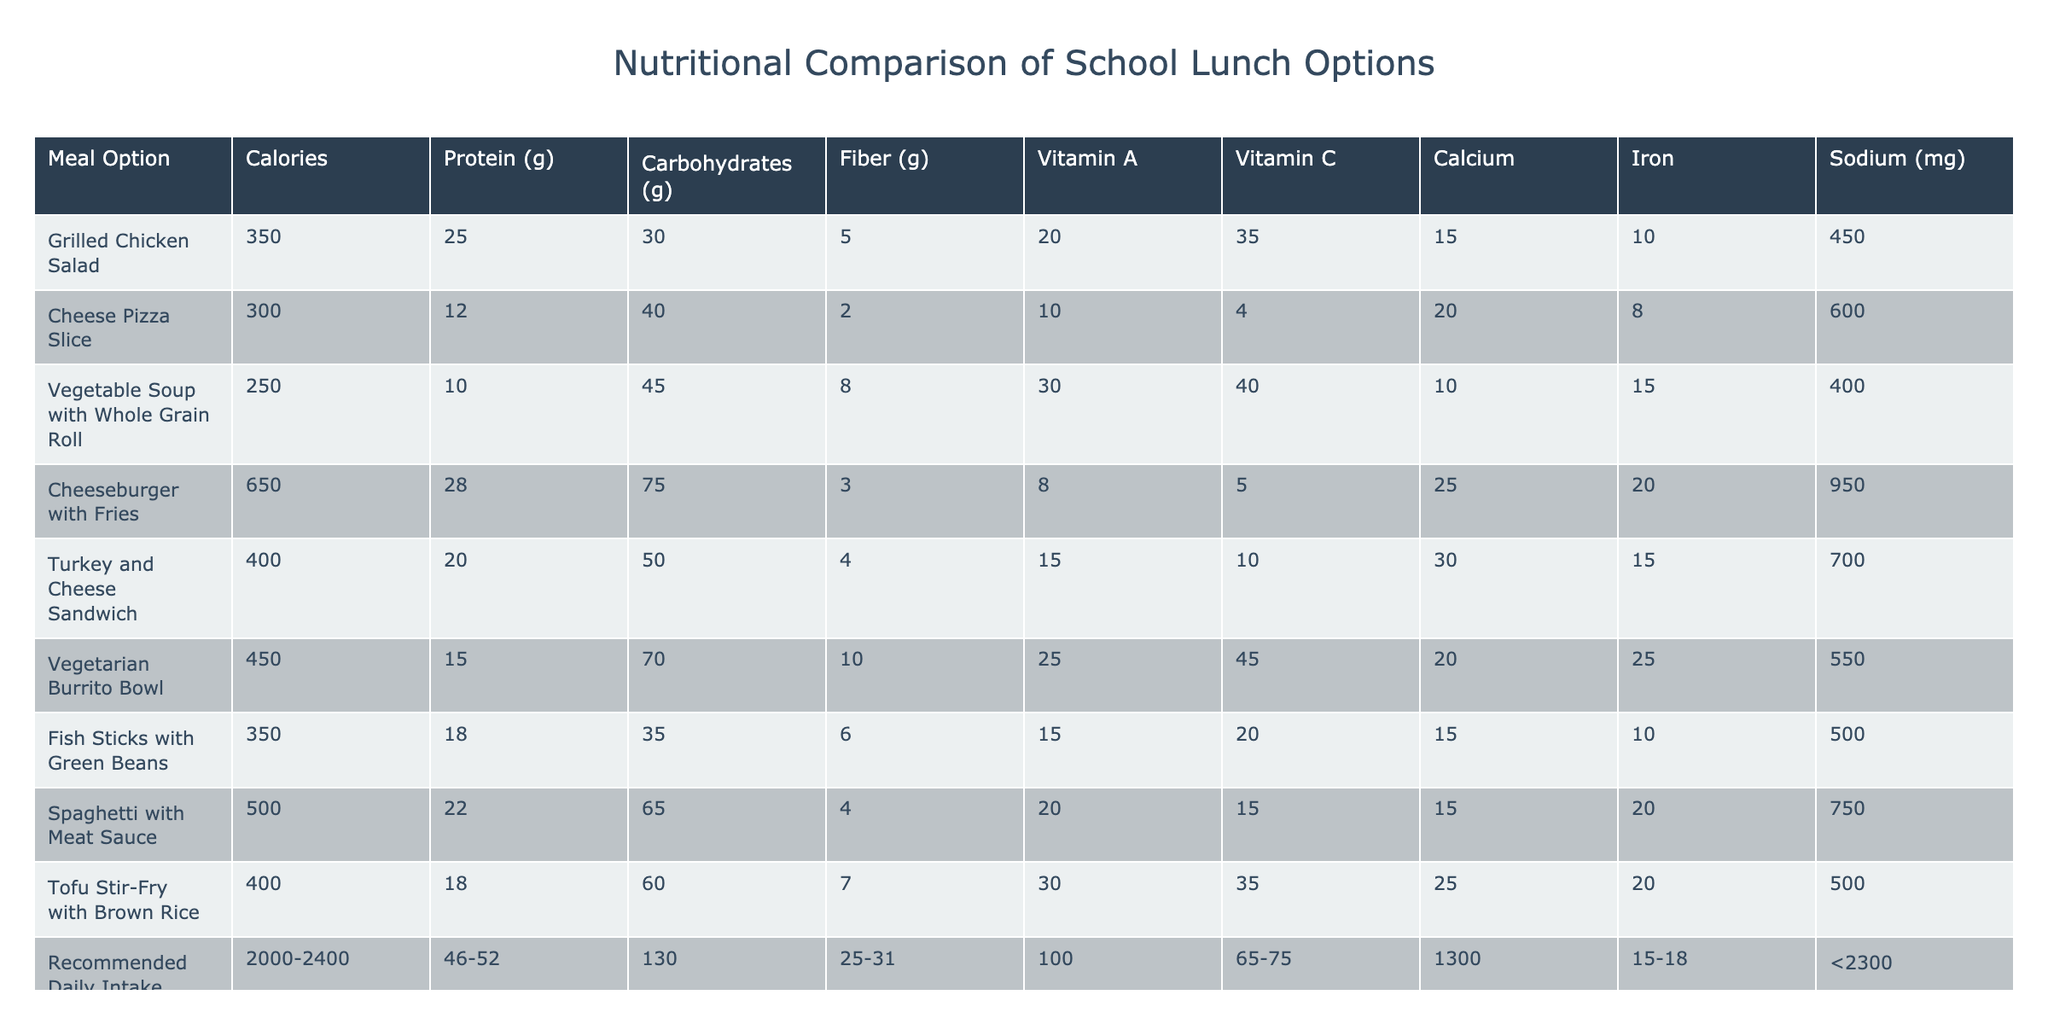What is the calorie content of the Cheeseburger with Fries? The table lists the Cheeseburger with Fries under the Meal Option column. Next to it, in the Calories column, the value is given as 650.
Answer: 650 Which meal option has the highest protein content? Looking at the Protein (g) column, the highest value is next to the Cheeseburger with Fries, which has 28 grams of protein.
Answer: Cheeseburger with Fries What is the total amount of Sodium in the Vegetarian Burrito Bowl and the Turkey and Cheese Sandwich combined? The Sodium content for the Vegetarian Burrito Bowl is 550 mg and for the Turkey and Cheese Sandwich, it is 700 mg. Adding these together gives 550 + 700 = 1250 mg.
Answer: 1250 mg Is the Cheese Pizza Slice above or below the recommended daily intake for Calcium? The recommended daily intake for Calcium is 1300 mg, while the Cheese Pizza Slice has 20% of the daily value. Converting this percentage to mg gives (20/100) * 1300 = 260 mg, which is below the recommended intake.
Answer: Below Which meal option has the highest Vitamin A content? The Vitamin A (%DV) column shows that Vegetable Soup with Whole Grain Roll has the highest value at 30% of the daily value.
Answer: Vegetable Soup with Whole Grain Roll What is the average fiber content of all meal options? The fiber values are 5, 2, 8, 3, 4, 10, 6, 4, and 7. Adding these gives 2 + 3 + 4 + 5 + 6 + 7 + 8 + 10 = 45. Dividing by the number of meal options (9) gives an average of 45/9 = 5.
Answer: 5 Is the Grilled Chicken Salad below the recommended intake for Vitamin C? The Grilled Chicken Salad has 35% of the daily value for Vitamin C, while the recommended intake is between 65-75%. Since 35% is less than both 65% and 75%, it is below the recommended intake.
Answer: Yes What is the difference in Calcium content between the Spaghetti with Meat Sauce and the Tofu Stir-Fry with Brown Rice? The Calcium content for Spaghetti with Meat Sauce is 15% and for Tofu Stir-Fry with Brown Rice is 25%. The difference is 25 - 15 = 10 percentage points.
Answer: 10 percentage points How many meal options exceed 500 calories? The meal options exceeding 500 calories are the Cheeseburger with Fries (650), the Spaghetti with Meat Sauce (500), and none of the others exceed this value. Thus, there are 2 meal options (Cheeseburger with Fries and Spaghetti with Meat Sauce).
Answer: 2 